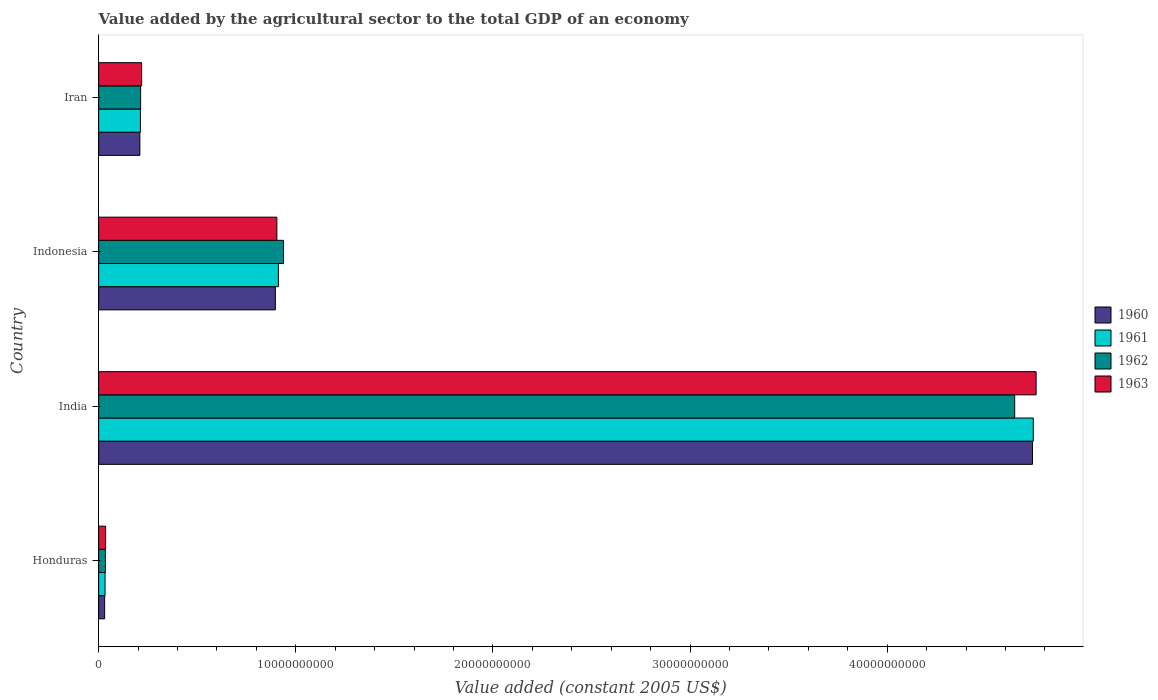How many groups of bars are there?
Offer a terse response. 4. Are the number of bars per tick equal to the number of legend labels?
Keep it short and to the point. Yes. Are the number of bars on each tick of the Y-axis equal?
Offer a very short reply. Yes. How many bars are there on the 4th tick from the bottom?
Your answer should be compact. 4. What is the label of the 4th group of bars from the top?
Your response must be concise. Honduras. What is the value added by the agricultural sector in 1962 in Honduras?
Your answer should be very brief. 3.41e+08. Across all countries, what is the maximum value added by the agricultural sector in 1963?
Ensure brevity in your answer.  4.76e+1. Across all countries, what is the minimum value added by the agricultural sector in 1960?
Provide a succinct answer. 3.05e+08. In which country was the value added by the agricultural sector in 1961 minimum?
Keep it short and to the point. Honduras. What is the total value added by the agricultural sector in 1962 in the graph?
Keep it short and to the point. 5.83e+1. What is the difference between the value added by the agricultural sector in 1962 in Honduras and that in Indonesia?
Offer a very short reply. -9.04e+09. What is the difference between the value added by the agricultural sector in 1962 in India and the value added by the agricultural sector in 1960 in Indonesia?
Keep it short and to the point. 3.75e+1. What is the average value added by the agricultural sector in 1961 per country?
Offer a very short reply. 1.47e+1. What is the difference between the value added by the agricultural sector in 1960 and value added by the agricultural sector in 1961 in Iran?
Ensure brevity in your answer.  -2.84e+07. What is the ratio of the value added by the agricultural sector in 1962 in Honduras to that in India?
Your answer should be compact. 0.01. Is the value added by the agricultural sector in 1963 in India less than that in Indonesia?
Provide a short and direct response. No. What is the difference between the highest and the second highest value added by the agricultural sector in 1962?
Make the answer very short. 3.71e+1. What is the difference between the highest and the lowest value added by the agricultural sector in 1963?
Provide a short and direct response. 4.72e+1. In how many countries, is the value added by the agricultural sector in 1962 greater than the average value added by the agricultural sector in 1962 taken over all countries?
Your answer should be very brief. 1. Is it the case that in every country, the sum of the value added by the agricultural sector in 1961 and value added by the agricultural sector in 1963 is greater than the sum of value added by the agricultural sector in 1962 and value added by the agricultural sector in 1960?
Make the answer very short. No. What does the 3rd bar from the top in Indonesia represents?
Offer a very short reply. 1961. Is it the case that in every country, the sum of the value added by the agricultural sector in 1963 and value added by the agricultural sector in 1962 is greater than the value added by the agricultural sector in 1961?
Make the answer very short. Yes. How many bars are there?
Ensure brevity in your answer.  16. Are all the bars in the graph horizontal?
Provide a short and direct response. Yes. How many countries are there in the graph?
Provide a succinct answer. 4. Are the values on the major ticks of X-axis written in scientific E-notation?
Provide a succinct answer. No. Does the graph contain any zero values?
Provide a short and direct response. No. Does the graph contain grids?
Provide a short and direct response. No. Where does the legend appear in the graph?
Give a very brief answer. Center right. How many legend labels are there?
Provide a succinct answer. 4. What is the title of the graph?
Give a very brief answer. Value added by the agricultural sector to the total GDP of an economy. What is the label or title of the X-axis?
Offer a terse response. Value added (constant 2005 US$). What is the label or title of the Y-axis?
Provide a succinct answer. Country. What is the Value added (constant 2005 US$) of 1960 in Honduras?
Provide a succinct answer. 3.05e+08. What is the Value added (constant 2005 US$) in 1961 in Honduras?
Keep it short and to the point. 3.25e+08. What is the Value added (constant 2005 US$) of 1962 in Honduras?
Keep it short and to the point. 3.41e+08. What is the Value added (constant 2005 US$) in 1963 in Honduras?
Provide a short and direct response. 3.53e+08. What is the Value added (constant 2005 US$) in 1960 in India?
Your response must be concise. 4.74e+1. What is the Value added (constant 2005 US$) of 1961 in India?
Keep it short and to the point. 4.74e+1. What is the Value added (constant 2005 US$) in 1962 in India?
Make the answer very short. 4.65e+1. What is the Value added (constant 2005 US$) in 1963 in India?
Keep it short and to the point. 4.76e+1. What is the Value added (constant 2005 US$) of 1960 in Indonesia?
Keep it short and to the point. 8.96e+09. What is the Value added (constant 2005 US$) in 1961 in Indonesia?
Provide a succinct answer. 9.12e+09. What is the Value added (constant 2005 US$) of 1962 in Indonesia?
Offer a very short reply. 9.38e+09. What is the Value added (constant 2005 US$) in 1963 in Indonesia?
Give a very brief answer. 9.04e+09. What is the Value added (constant 2005 US$) of 1960 in Iran?
Provide a succinct answer. 2.09e+09. What is the Value added (constant 2005 US$) of 1961 in Iran?
Offer a terse response. 2.12e+09. What is the Value added (constant 2005 US$) in 1962 in Iran?
Provide a short and direct response. 2.13e+09. What is the Value added (constant 2005 US$) in 1963 in Iran?
Keep it short and to the point. 2.18e+09. Across all countries, what is the maximum Value added (constant 2005 US$) in 1960?
Your answer should be compact. 4.74e+1. Across all countries, what is the maximum Value added (constant 2005 US$) in 1961?
Your response must be concise. 4.74e+1. Across all countries, what is the maximum Value added (constant 2005 US$) in 1962?
Your answer should be compact. 4.65e+1. Across all countries, what is the maximum Value added (constant 2005 US$) of 1963?
Make the answer very short. 4.76e+1. Across all countries, what is the minimum Value added (constant 2005 US$) in 1960?
Give a very brief answer. 3.05e+08. Across all countries, what is the minimum Value added (constant 2005 US$) in 1961?
Provide a succinct answer. 3.25e+08. Across all countries, what is the minimum Value added (constant 2005 US$) of 1962?
Keep it short and to the point. 3.41e+08. Across all countries, what is the minimum Value added (constant 2005 US$) in 1963?
Your response must be concise. 3.53e+08. What is the total Value added (constant 2005 US$) in 1960 in the graph?
Offer a terse response. 5.87e+1. What is the total Value added (constant 2005 US$) of 1961 in the graph?
Offer a terse response. 5.90e+1. What is the total Value added (constant 2005 US$) in 1962 in the graph?
Ensure brevity in your answer.  5.83e+1. What is the total Value added (constant 2005 US$) in 1963 in the graph?
Make the answer very short. 5.91e+1. What is the difference between the Value added (constant 2005 US$) of 1960 in Honduras and that in India?
Ensure brevity in your answer.  -4.71e+1. What is the difference between the Value added (constant 2005 US$) of 1961 in Honduras and that in India?
Make the answer very short. -4.71e+1. What is the difference between the Value added (constant 2005 US$) in 1962 in Honduras and that in India?
Your answer should be very brief. -4.61e+1. What is the difference between the Value added (constant 2005 US$) of 1963 in Honduras and that in India?
Your answer should be compact. -4.72e+1. What is the difference between the Value added (constant 2005 US$) in 1960 in Honduras and that in Indonesia?
Ensure brevity in your answer.  -8.66e+09. What is the difference between the Value added (constant 2005 US$) in 1961 in Honduras and that in Indonesia?
Give a very brief answer. -8.79e+09. What is the difference between the Value added (constant 2005 US$) in 1962 in Honduras and that in Indonesia?
Keep it short and to the point. -9.04e+09. What is the difference between the Value added (constant 2005 US$) of 1963 in Honduras and that in Indonesia?
Offer a very short reply. -8.69e+09. What is the difference between the Value added (constant 2005 US$) in 1960 in Honduras and that in Iran?
Your answer should be very brief. -1.79e+09. What is the difference between the Value added (constant 2005 US$) of 1961 in Honduras and that in Iran?
Keep it short and to the point. -1.79e+09. What is the difference between the Value added (constant 2005 US$) in 1962 in Honduras and that in Iran?
Give a very brief answer. -1.79e+09. What is the difference between the Value added (constant 2005 US$) in 1963 in Honduras and that in Iran?
Give a very brief answer. -1.83e+09. What is the difference between the Value added (constant 2005 US$) of 1960 in India and that in Indonesia?
Keep it short and to the point. 3.84e+1. What is the difference between the Value added (constant 2005 US$) of 1961 in India and that in Indonesia?
Provide a succinct answer. 3.83e+1. What is the difference between the Value added (constant 2005 US$) in 1962 in India and that in Indonesia?
Your answer should be very brief. 3.71e+1. What is the difference between the Value added (constant 2005 US$) in 1963 in India and that in Indonesia?
Offer a very short reply. 3.85e+1. What is the difference between the Value added (constant 2005 US$) of 1960 in India and that in Iran?
Provide a short and direct response. 4.53e+1. What is the difference between the Value added (constant 2005 US$) of 1961 in India and that in Iran?
Keep it short and to the point. 4.53e+1. What is the difference between the Value added (constant 2005 US$) in 1962 in India and that in Iran?
Provide a short and direct response. 4.43e+1. What is the difference between the Value added (constant 2005 US$) of 1963 in India and that in Iran?
Your response must be concise. 4.54e+1. What is the difference between the Value added (constant 2005 US$) in 1960 in Indonesia and that in Iran?
Offer a very short reply. 6.87e+09. What is the difference between the Value added (constant 2005 US$) of 1961 in Indonesia and that in Iran?
Offer a very short reply. 7.00e+09. What is the difference between the Value added (constant 2005 US$) in 1962 in Indonesia and that in Iran?
Offer a terse response. 7.25e+09. What is the difference between the Value added (constant 2005 US$) of 1963 in Indonesia and that in Iran?
Offer a very short reply. 6.86e+09. What is the difference between the Value added (constant 2005 US$) in 1960 in Honduras and the Value added (constant 2005 US$) in 1961 in India?
Ensure brevity in your answer.  -4.71e+1. What is the difference between the Value added (constant 2005 US$) of 1960 in Honduras and the Value added (constant 2005 US$) of 1962 in India?
Your response must be concise. -4.62e+1. What is the difference between the Value added (constant 2005 US$) of 1960 in Honduras and the Value added (constant 2005 US$) of 1963 in India?
Your answer should be very brief. -4.72e+1. What is the difference between the Value added (constant 2005 US$) of 1961 in Honduras and the Value added (constant 2005 US$) of 1962 in India?
Provide a short and direct response. -4.61e+1. What is the difference between the Value added (constant 2005 US$) in 1961 in Honduras and the Value added (constant 2005 US$) in 1963 in India?
Your answer should be compact. -4.72e+1. What is the difference between the Value added (constant 2005 US$) of 1962 in Honduras and the Value added (constant 2005 US$) of 1963 in India?
Offer a very short reply. -4.72e+1. What is the difference between the Value added (constant 2005 US$) in 1960 in Honduras and the Value added (constant 2005 US$) in 1961 in Indonesia?
Offer a very short reply. -8.81e+09. What is the difference between the Value added (constant 2005 US$) of 1960 in Honduras and the Value added (constant 2005 US$) of 1962 in Indonesia?
Keep it short and to the point. -9.07e+09. What is the difference between the Value added (constant 2005 US$) of 1960 in Honduras and the Value added (constant 2005 US$) of 1963 in Indonesia?
Provide a short and direct response. -8.73e+09. What is the difference between the Value added (constant 2005 US$) of 1961 in Honduras and the Value added (constant 2005 US$) of 1962 in Indonesia?
Your answer should be very brief. -9.05e+09. What is the difference between the Value added (constant 2005 US$) in 1961 in Honduras and the Value added (constant 2005 US$) in 1963 in Indonesia?
Your answer should be very brief. -8.72e+09. What is the difference between the Value added (constant 2005 US$) in 1962 in Honduras and the Value added (constant 2005 US$) in 1963 in Indonesia?
Provide a succinct answer. -8.70e+09. What is the difference between the Value added (constant 2005 US$) of 1960 in Honduras and the Value added (constant 2005 US$) of 1961 in Iran?
Provide a succinct answer. -1.81e+09. What is the difference between the Value added (constant 2005 US$) of 1960 in Honduras and the Value added (constant 2005 US$) of 1962 in Iran?
Offer a very short reply. -1.82e+09. What is the difference between the Value added (constant 2005 US$) in 1960 in Honduras and the Value added (constant 2005 US$) in 1963 in Iran?
Offer a terse response. -1.88e+09. What is the difference between the Value added (constant 2005 US$) in 1961 in Honduras and the Value added (constant 2005 US$) in 1962 in Iran?
Your response must be concise. -1.80e+09. What is the difference between the Value added (constant 2005 US$) of 1961 in Honduras and the Value added (constant 2005 US$) of 1963 in Iran?
Your response must be concise. -1.86e+09. What is the difference between the Value added (constant 2005 US$) in 1962 in Honduras and the Value added (constant 2005 US$) in 1963 in Iran?
Give a very brief answer. -1.84e+09. What is the difference between the Value added (constant 2005 US$) of 1960 in India and the Value added (constant 2005 US$) of 1961 in Indonesia?
Offer a very short reply. 3.83e+1. What is the difference between the Value added (constant 2005 US$) in 1960 in India and the Value added (constant 2005 US$) in 1962 in Indonesia?
Provide a succinct answer. 3.80e+1. What is the difference between the Value added (constant 2005 US$) of 1960 in India and the Value added (constant 2005 US$) of 1963 in Indonesia?
Make the answer very short. 3.83e+1. What is the difference between the Value added (constant 2005 US$) in 1961 in India and the Value added (constant 2005 US$) in 1962 in Indonesia?
Give a very brief answer. 3.80e+1. What is the difference between the Value added (constant 2005 US$) of 1961 in India and the Value added (constant 2005 US$) of 1963 in Indonesia?
Give a very brief answer. 3.84e+1. What is the difference between the Value added (constant 2005 US$) of 1962 in India and the Value added (constant 2005 US$) of 1963 in Indonesia?
Your answer should be compact. 3.74e+1. What is the difference between the Value added (constant 2005 US$) of 1960 in India and the Value added (constant 2005 US$) of 1961 in Iran?
Offer a terse response. 4.52e+1. What is the difference between the Value added (constant 2005 US$) in 1960 in India and the Value added (constant 2005 US$) in 1962 in Iran?
Your answer should be very brief. 4.52e+1. What is the difference between the Value added (constant 2005 US$) of 1960 in India and the Value added (constant 2005 US$) of 1963 in Iran?
Offer a very short reply. 4.52e+1. What is the difference between the Value added (constant 2005 US$) of 1961 in India and the Value added (constant 2005 US$) of 1962 in Iran?
Make the answer very short. 4.53e+1. What is the difference between the Value added (constant 2005 US$) of 1961 in India and the Value added (constant 2005 US$) of 1963 in Iran?
Provide a succinct answer. 4.52e+1. What is the difference between the Value added (constant 2005 US$) of 1962 in India and the Value added (constant 2005 US$) of 1963 in Iran?
Make the answer very short. 4.43e+1. What is the difference between the Value added (constant 2005 US$) of 1960 in Indonesia and the Value added (constant 2005 US$) of 1961 in Iran?
Provide a short and direct response. 6.84e+09. What is the difference between the Value added (constant 2005 US$) of 1960 in Indonesia and the Value added (constant 2005 US$) of 1962 in Iran?
Make the answer very short. 6.83e+09. What is the difference between the Value added (constant 2005 US$) of 1960 in Indonesia and the Value added (constant 2005 US$) of 1963 in Iran?
Offer a terse response. 6.78e+09. What is the difference between the Value added (constant 2005 US$) of 1961 in Indonesia and the Value added (constant 2005 US$) of 1962 in Iran?
Make the answer very short. 6.99e+09. What is the difference between the Value added (constant 2005 US$) of 1961 in Indonesia and the Value added (constant 2005 US$) of 1963 in Iran?
Give a very brief answer. 6.94e+09. What is the difference between the Value added (constant 2005 US$) of 1962 in Indonesia and the Value added (constant 2005 US$) of 1963 in Iran?
Your response must be concise. 7.20e+09. What is the average Value added (constant 2005 US$) in 1960 per country?
Offer a very short reply. 1.47e+1. What is the average Value added (constant 2005 US$) in 1961 per country?
Offer a terse response. 1.47e+1. What is the average Value added (constant 2005 US$) in 1962 per country?
Offer a terse response. 1.46e+1. What is the average Value added (constant 2005 US$) in 1963 per country?
Keep it short and to the point. 1.48e+1. What is the difference between the Value added (constant 2005 US$) of 1960 and Value added (constant 2005 US$) of 1961 in Honduras?
Offer a very short reply. -1.99e+07. What is the difference between the Value added (constant 2005 US$) of 1960 and Value added (constant 2005 US$) of 1962 in Honduras?
Give a very brief answer. -3.54e+07. What is the difference between the Value added (constant 2005 US$) of 1960 and Value added (constant 2005 US$) of 1963 in Honduras?
Your answer should be very brief. -4.78e+07. What is the difference between the Value added (constant 2005 US$) in 1961 and Value added (constant 2005 US$) in 1962 in Honduras?
Your answer should be compact. -1.55e+07. What is the difference between the Value added (constant 2005 US$) of 1961 and Value added (constant 2005 US$) of 1963 in Honduras?
Offer a terse response. -2.79e+07. What is the difference between the Value added (constant 2005 US$) of 1962 and Value added (constant 2005 US$) of 1963 in Honduras?
Keep it short and to the point. -1.24e+07. What is the difference between the Value added (constant 2005 US$) of 1960 and Value added (constant 2005 US$) of 1961 in India?
Make the answer very short. -3.99e+07. What is the difference between the Value added (constant 2005 US$) of 1960 and Value added (constant 2005 US$) of 1962 in India?
Give a very brief answer. 9.03e+08. What is the difference between the Value added (constant 2005 US$) of 1960 and Value added (constant 2005 US$) of 1963 in India?
Keep it short and to the point. -1.84e+08. What is the difference between the Value added (constant 2005 US$) of 1961 and Value added (constant 2005 US$) of 1962 in India?
Offer a very short reply. 9.43e+08. What is the difference between the Value added (constant 2005 US$) in 1961 and Value added (constant 2005 US$) in 1963 in India?
Provide a succinct answer. -1.44e+08. What is the difference between the Value added (constant 2005 US$) in 1962 and Value added (constant 2005 US$) in 1963 in India?
Offer a very short reply. -1.09e+09. What is the difference between the Value added (constant 2005 US$) of 1960 and Value added (constant 2005 US$) of 1961 in Indonesia?
Make the answer very short. -1.54e+08. What is the difference between the Value added (constant 2005 US$) of 1960 and Value added (constant 2005 US$) of 1962 in Indonesia?
Make the answer very short. -4.16e+08. What is the difference between the Value added (constant 2005 US$) in 1960 and Value added (constant 2005 US$) in 1963 in Indonesia?
Offer a very short reply. -7.71e+07. What is the difference between the Value added (constant 2005 US$) in 1961 and Value added (constant 2005 US$) in 1962 in Indonesia?
Offer a very short reply. -2.62e+08. What is the difference between the Value added (constant 2005 US$) of 1961 and Value added (constant 2005 US$) of 1963 in Indonesia?
Give a very brief answer. 7.71e+07. What is the difference between the Value added (constant 2005 US$) in 1962 and Value added (constant 2005 US$) in 1963 in Indonesia?
Ensure brevity in your answer.  3.39e+08. What is the difference between the Value added (constant 2005 US$) in 1960 and Value added (constant 2005 US$) in 1961 in Iran?
Make the answer very short. -2.84e+07. What is the difference between the Value added (constant 2005 US$) in 1960 and Value added (constant 2005 US$) in 1962 in Iran?
Your answer should be very brief. -3.89e+07. What is the difference between the Value added (constant 2005 US$) in 1960 and Value added (constant 2005 US$) in 1963 in Iran?
Give a very brief answer. -9.02e+07. What is the difference between the Value added (constant 2005 US$) in 1961 and Value added (constant 2005 US$) in 1962 in Iran?
Your answer should be very brief. -1.05e+07. What is the difference between the Value added (constant 2005 US$) of 1961 and Value added (constant 2005 US$) of 1963 in Iran?
Keep it short and to the point. -6.18e+07. What is the difference between the Value added (constant 2005 US$) in 1962 and Value added (constant 2005 US$) in 1963 in Iran?
Ensure brevity in your answer.  -5.13e+07. What is the ratio of the Value added (constant 2005 US$) of 1960 in Honduras to that in India?
Ensure brevity in your answer.  0.01. What is the ratio of the Value added (constant 2005 US$) in 1961 in Honduras to that in India?
Ensure brevity in your answer.  0.01. What is the ratio of the Value added (constant 2005 US$) of 1962 in Honduras to that in India?
Ensure brevity in your answer.  0.01. What is the ratio of the Value added (constant 2005 US$) in 1963 in Honduras to that in India?
Your response must be concise. 0.01. What is the ratio of the Value added (constant 2005 US$) of 1960 in Honduras to that in Indonesia?
Provide a succinct answer. 0.03. What is the ratio of the Value added (constant 2005 US$) in 1961 in Honduras to that in Indonesia?
Give a very brief answer. 0.04. What is the ratio of the Value added (constant 2005 US$) in 1962 in Honduras to that in Indonesia?
Offer a terse response. 0.04. What is the ratio of the Value added (constant 2005 US$) in 1963 in Honduras to that in Indonesia?
Offer a terse response. 0.04. What is the ratio of the Value added (constant 2005 US$) in 1960 in Honduras to that in Iran?
Offer a terse response. 0.15. What is the ratio of the Value added (constant 2005 US$) of 1961 in Honduras to that in Iran?
Your response must be concise. 0.15. What is the ratio of the Value added (constant 2005 US$) in 1962 in Honduras to that in Iran?
Provide a short and direct response. 0.16. What is the ratio of the Value added (constant 2005 US$) in 1963 in Honduras to that in Iran?
Ensure brevity in your answer.  0.16. What is the ratio of the Value added (constant 2005 US$) in 1960 in India to that in Indonesia?
Provide a short and direct response. 5.28. What is the ratio of the Value added (constant 2005 US$) in 1961 in India to that in Indonesia?
Make the answer very short. 5.2. What is the ratio of the Value added (constant 2005 US$) in 1962 in India to that in Indonesia?
Your response must be concise. 4.95. What is the ratio of the Value added (constant 2005 US$) in 1963 in India to that in Indonesia?
Provide a succinct answer. 5.26. What is the ratio of the Value added (constant 2005 US$) of 1960 in India to that in Iran?
Ensure brevity in your answer.  22.65. What is the ratio of the Value added (constant 2005 US$) of 1961 in India to that in Iran?
Keep it short and to the point. 22.37. What is the ratio of the Value added (constant 2005 US$) of 1962 in India to that in Iran?
Your answer should be very brief. 21.81. What is the ratio of the Value added (constant 2005 US$) of 1963 in India to that in Iran?
Give a very brief answer. 21.8. What is the ratio of the Value added (constant 2005 US$) of 1960 in Indonesia to that in Iran?
Your answer should be compact. 4.29. What is the ratio of the Value added (constant 2005 US$) in 1961 in Indonesia to that in Iran?
Provide a succinct answer. 4.3. What is the ratio of the Value added (constant 2005 US$) in 1962 in Indonesia to that in Iran?
Provide a short and direct response. 4.4. What is the ratio of the Value added (constant 2005 US$) in 1963 in Indonesia to that in Iran?
Your answer should be compact. 4.14. What is the difference between the highest and the second highest Value added (constant 2005 US$) in 1960?
Give a very brief answer. 3.84e+1. What is the difference between the highest and the second highest Value added (constant 2005 US$) of 1961?
Your response must be concise. 3.83e+1. What is the difference between the highest and the second highest Value added (constant 2005 US$) of 1962?
Offer a very short reply. 3.71e+1. What is the difference between the highest and the second highest Value added (constant 2005 US$) of 1963?
Provide a succinct answer. 3.85e+1. What is the difference between the highest and the lowest Value added (constant 2005 US$) of 1960?
Your response must be concise. 4.71e+1. What is the difference between the highest and the lowest Value added (constant 2005 US$) of 1961?
Your answer should be compact. 4.71e+1. What is the difference between the highest and the lowest Value added (constant 2005 US$) of 1962?
Offer a very short reply. 4.61e+1. What is the difference between the highest and the lowest Value added (constant 2005 US$) of 1963?
Ensure brevity in your answer.  4.72e+1. 